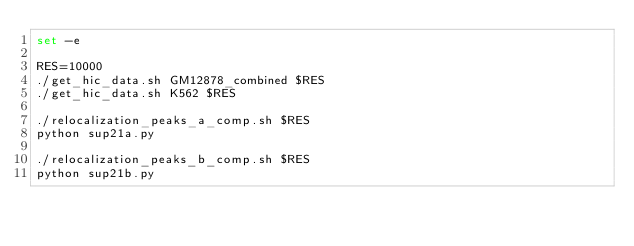<code> <loc_0><loc_0><loc_500><loc_500><_Bash_>set -e

RES=10000
./get_hic_data.sh GM12878_combined $RES
./get_hic_data.sh K562 $RES

./relocalization_peaks_a_comp.sh $RES
python sup21a.py

./relocalization_peaks_b_comp.sh $RES
python sup21b.py
</code> 